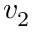Convert formula to latex. <formula><loc_0><loc_0><loc_500><loc_500>v _ { 2 }</formula> 